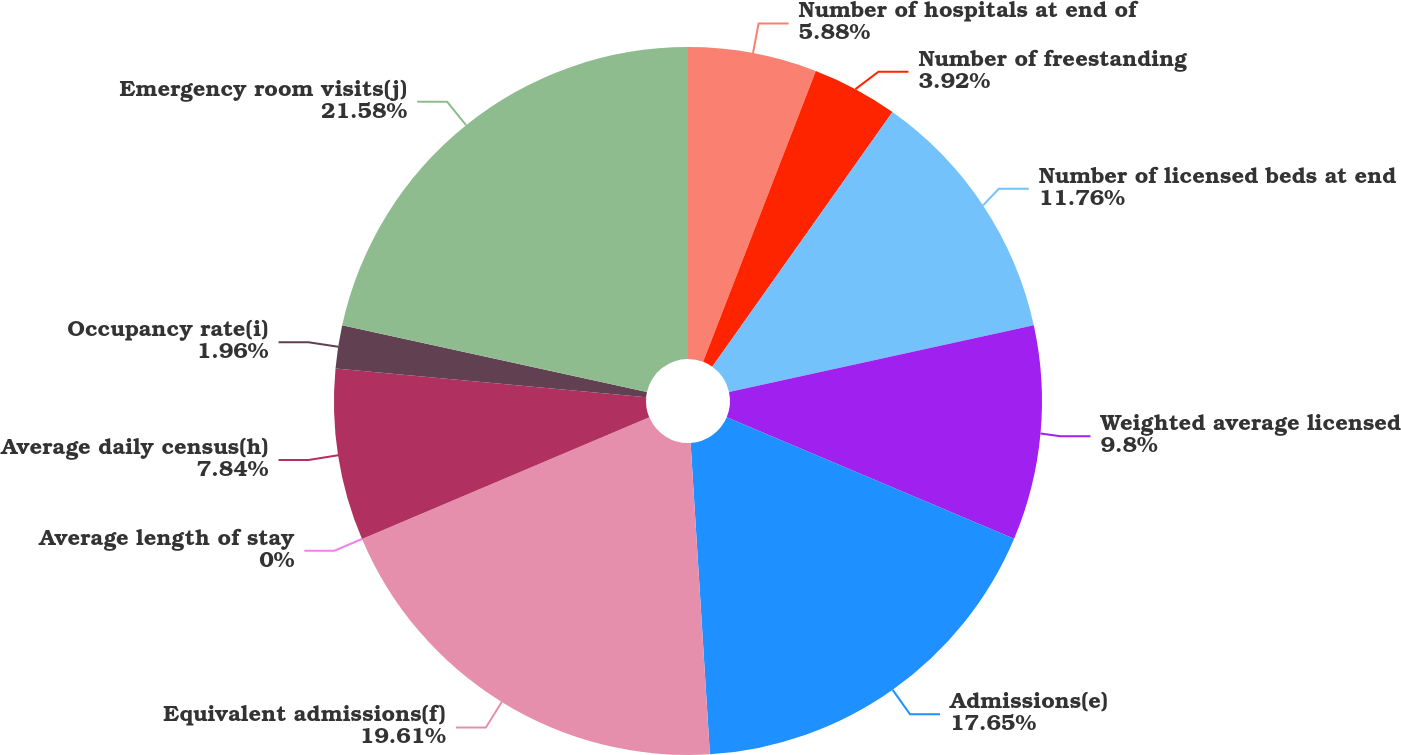<chart> <loc_0><loc_0><loc_500><loc_500><pie_chart><fcel>Number of hospitals at end of<fcel>Number of freestanding<fcel>Number of licensed beds at end<fcel>Weighted average licensed<fcel>Admissions(e)<fcel>Equivalent admissions(f)<fcel>Average length of stay<fcel>Average daily census(h)<fcel>Occupancy rate(i)<fcel>Emergency room visits(j)<nl><fcel>5.88%<fcel>3.92%<fcel>11.76%<fcel>9.8%<fcel>17.65%<fcel>19.61%<fcel>0.0%<fcel>7.84%<fcel>1.96%<fcel>21.57%<nl></chart> 